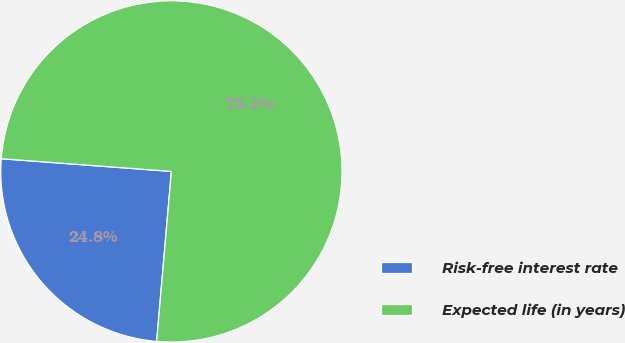Convert chart. <chart><loc_0><loc_0><loc_500><loc_500><pie_chart><fcel>Risk-free interest rate<fcel>Expected life (in years)<nl><fcel>24.81%<fcel>75.19%<nl></chart> 